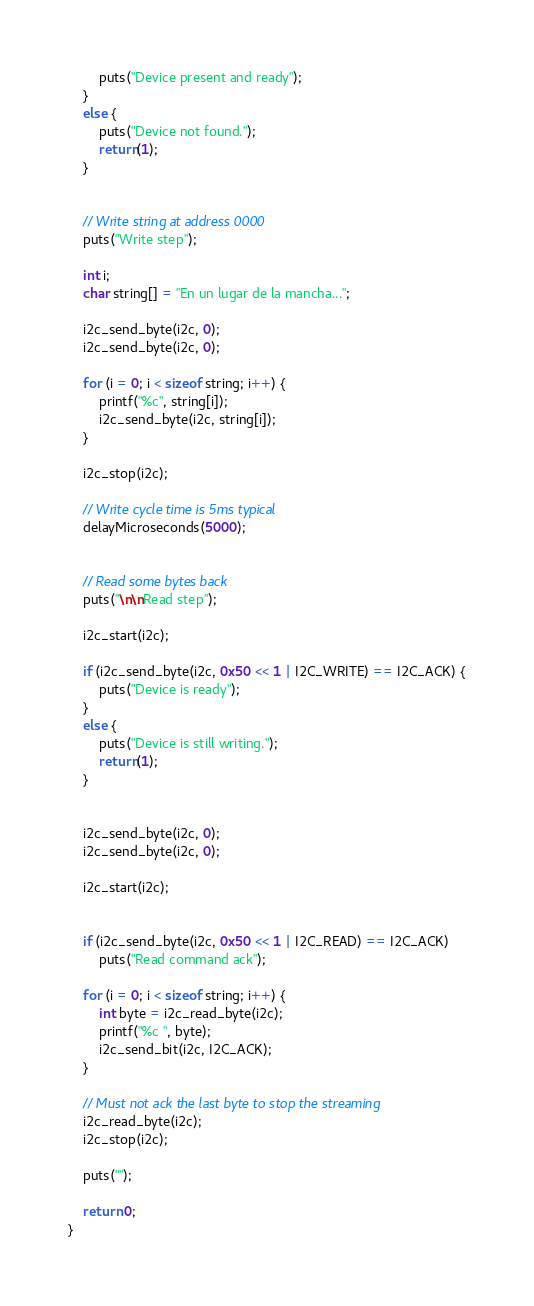Convert code to text. <code><loc_0><loc_0><loc_500><loc_500><_C_>		puts("Device present and ready");
	}
	else {
		puts("Device not found.");
		return(1);
	}


	// Write string at address 0000
	puts("Write step");

	int i;
	char string[] = "En un lugar de la mancha...";
	
	i2c_send_byte(i2c, 0);
	i2c_send_byte(i2c, 0);

	for (i = 0; i < sizeof string; i++) {
		printf("%c", string[i]);
		i2c_send_byte(i2c, string[i]);
	}

	i2c_stop(i2c);

	// Write cycle time is 5ms typical
	delayMicroseconds(5000);

	
	// Read some bytes back
	puts("\n\nRead step");

	i2c_start(i2c);

	if (i2c_send_byte(i2c, 0x50 << 1 | I2C_WRITE) == I2C_ACK) {
		puts("Device is ready");
	}
	else {
		puts("Device is still writing.");
		return(1);
	}


	i2c_send_byte(i2c, 0);
	i2c_send_byte(i2c, 0);

	i2c_start(i2c);

	
	if (i2c_send_byte(i2c, 0x50 << 1 | I2C_READ) == I2C_ACK)
		puts("Read command ack");

	for (i = 0; i < sizeof string; i++) {
		int byte = i2c_read_byte(i2c);
		printf("%c ", byte);
		i2c_send_bit(i2c, I2C_ACK);
	}

	// Must not ack the last byte to stop the streaming
	i2c_read_byte(i2c);
	i2c_stop(i2c);

	puts("");

	return 0;
}
</code> 